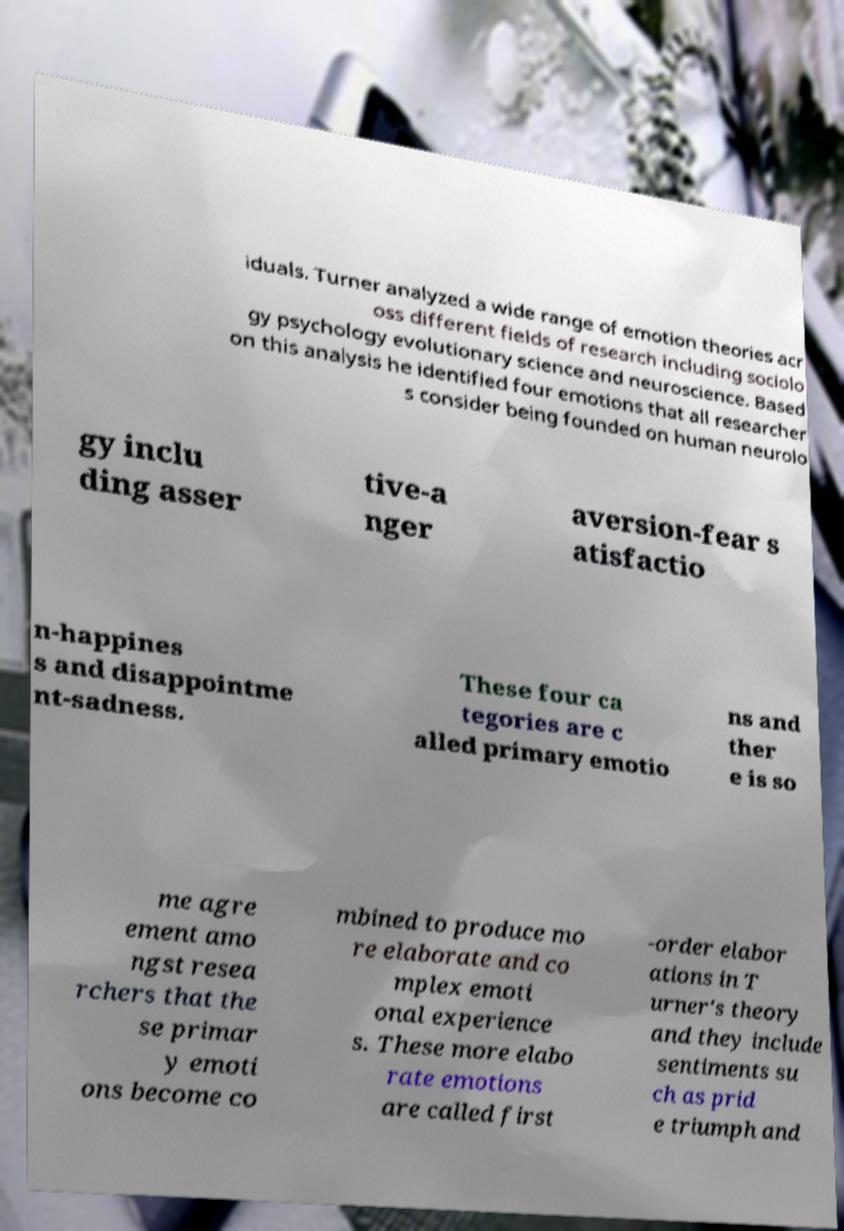Please read and relay the text visible in this image. What does it say? iduals. Turner analyzed a wide range of emotion theories acr oss different fields of research including sociolo gy psychology evolutionary science and neuroscience. Based on this analysis he identified four emotions that all researcher s consider being founded on human neurolo gy inclu ding asser tive-a nger aversion-fear s atisfactio n-happines s and disappointme nt-sadness. These four ca tegories are c alled primary emotio ns and ther e is so me agre ement amo ngst resea rchers that the se primar y emoti ons become co mbined to produce mo re elaborate and co mplex emoti onal experience s. These more elabo rate emotions are called first -order elabor ations in T urner's theory and they include sentiments su ch as prid e triumph and 